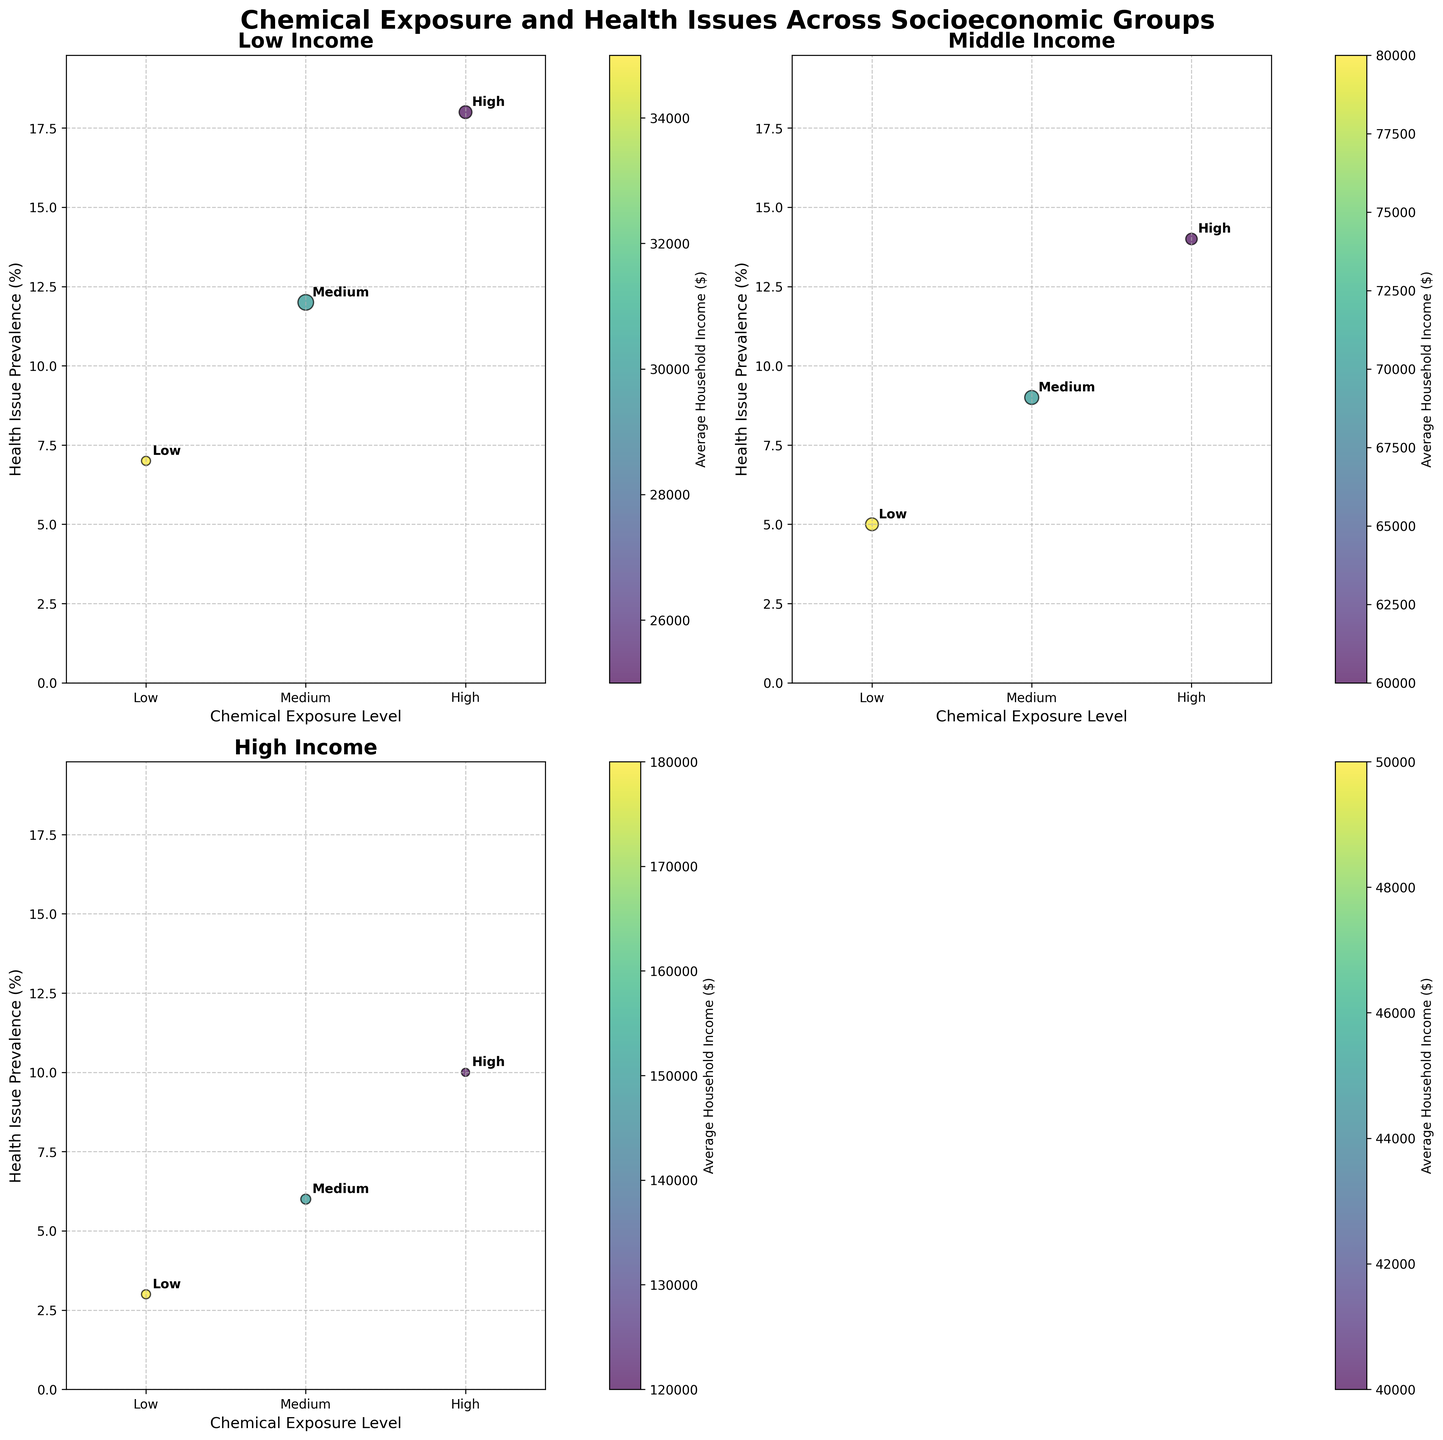what is the title of the figure? The title is displayed in bold at the top of the figure. It reads "Chemical Exposure and Health Issues Across Socioeconomic Groups".
Answer: Chemical Exposure and Health Issues Across Socioeconomic Groups How many socioeconomic groups are represented in the figure? There are four subplots, each representing a different socioeconomic group: Low Income, Middle Income, High Income, and Rural. The Urban group is not included because the last subplot was removed.
Answer: Four What is the highest health issue prevalence in the Low Income group? In the Low Income group subplot, the highest bubble (y-axis) corresponds to a Health Issue Prevalence of 18% under High Chemical Exposure.
Answer: 18% Which socioeconomic group shows the lowest health issue prevalence? By looking at the y-axis values across each subplot, the High Income group has the lowest health issue prevalence at 3% under Low Chemical Exposure.
Answer: High Income Compare the health issue prevalence between Rural and Urban groups at High Chemical Exposure. For High Chemical Exposure: In the Rural group, the prevalence is at 16%; In the Urban group, it is at 15%.
Answer: Rural: 16%, Urban: 15% What is the general trend between chemical exposure levels and health issue prevalence? Across all socioeconomic groups, as the level of chemical exposure increases from Low to High, the health issue prevalence generally increases.
Answer: Increases How does household income vary with chemical exposure level in the Middle Income group? In the Middle Income subplot, the color scale bar indicates income. Darker shades represent higher income. As chemical exposure levels decrease from High to Low, the color gets darker, indicating higher income with lower chemical exposure.
Answer: Higher income with lower chemical exposure Are there any subplots with a negative correlation between chemical exposure and health issues? No, across all subplots (Low Income, Middle Income, High Income, Rural, and Urban), the correlation between chemical exposure levels and health issue prevalence is positive.
Answer: No Between Middle Income and High Income groups, which one shows a clearer distinction between the bubbles in terms of size for different levels of exposure? In the High Income group, bubble sizes represent a clearer distinction between population sizes for different chemical exposure levels compared to the Middle Income group. High Income has smaller, more distinct bubbles for Low exposure.
Answer: High Income 